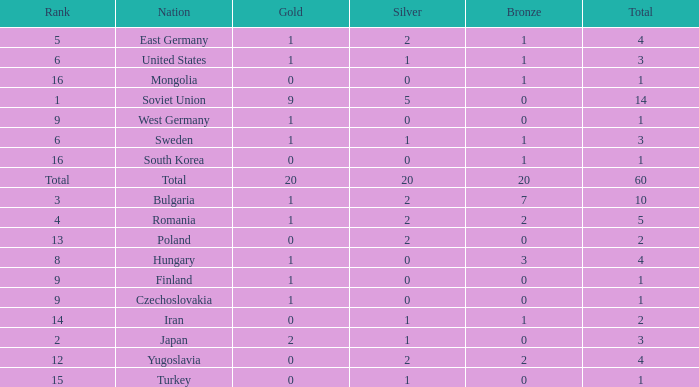What is the number of totals that have silvers under 2, bronzes over 0, and golds over 1? 0.0. 